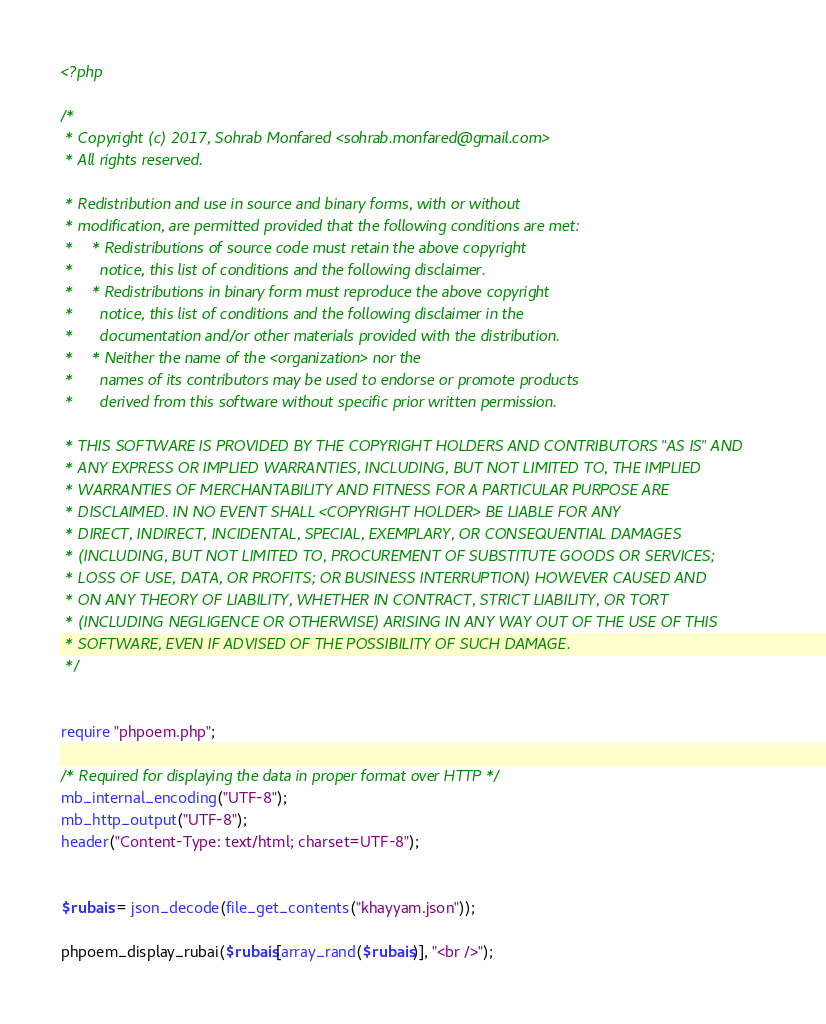Convert code to text. <code><loc_0><loc_0><loc_500><loc_500><_PHP_><?php

/*
 * Copyright (c) 2017, Sohrab Monfared <sohrab.monfared@gmail.com>
 * All rights reserved.

 * Redistribution and use in source and binary forms, with or without
 * modification, are permitted provided that the following conditions are met:
 *    * Redistributions of source code must retain the above copyright
 *      notice, this list of conditions and the following disclaimer.
 *    * Redistributions in binary form must reproduce the above copyright
 *      notice, this list of conditions and the following disclaimer in the
 *      documentation and/or other materials provided with the distribution.
 *    * Neither the name of the <organization> nor the
 *      names of its contributors may be used to endorse or promote products
 *      derived from this software without specific prior written permission.

 * THIS SOFTWARE IS PROVIDED BY THE COPYRIGHT HOLDERS AND CONTRIBUTORS "AS IS" AND
 * ANY EXPRESS OR IMPLIED WARRANTIES, INCLUDING, BUT NOT LIMITED TO, THE IMPLIED
 * WARRANTIES OF MERCHANTABILITY AND FITNESS FOR A PARTICULAR PURPOSE ARE
 * DISCLAIMED. IN NO EVENT SHALL <COPYRIGHT HOLDER> BE LIABLE FOR ANY
 * DIRECT, INDIRECT, INCIDENTAL, SPECIAL, EXEMPLARY, OR CONSEQUENTIAL DAMAGES
 * (INCLUDING, BUT NOT LIMITED TO, PROCUREMENT OF SUBSTITUTE GOODS OR SERVICES;
 * LOSS OF USE, DATA, OR PROFITS; OR BUSINESS INTERRUPTION) HOWEVER CAUSED AND
 * ON ANY THEORY OF LIABILITY, WHETHER IN CONTRACT, STRICT LIABILITY, OR TORT
 * (INCLUDING NEGLIGENCE OR OTHERWISE) ARISING IN ANY WAY OUT OF THE USE OF THIS
 * SOFTWARE, EVEN IF ADVISED OF THE POSSIBILITY OF SUCH DAMAGE.
 */


require "phpoem.php";

/* Required for displaying the data in proper format over HTTP */
mb_internal_encoding("UTF-8");
mb_http_output("UTF-8");
header("Content-Type: text/html; charset=UTF-8");


$rubais = json_decode(file_get_contents("khayyam.json"));

phpoem_display_rubai($rubais[array_rand($rubais)], "<br />");
</code> 